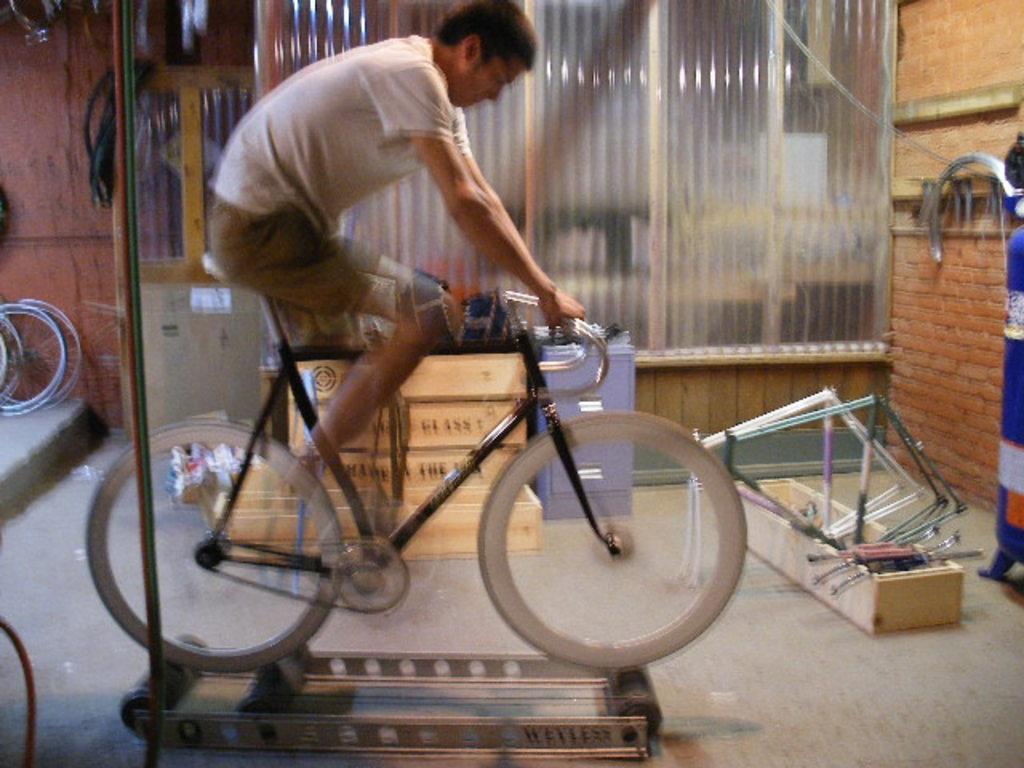Please provide a concise description of this image. This man is riding a bicycle. Far there are bicycles. On floor there are things. 